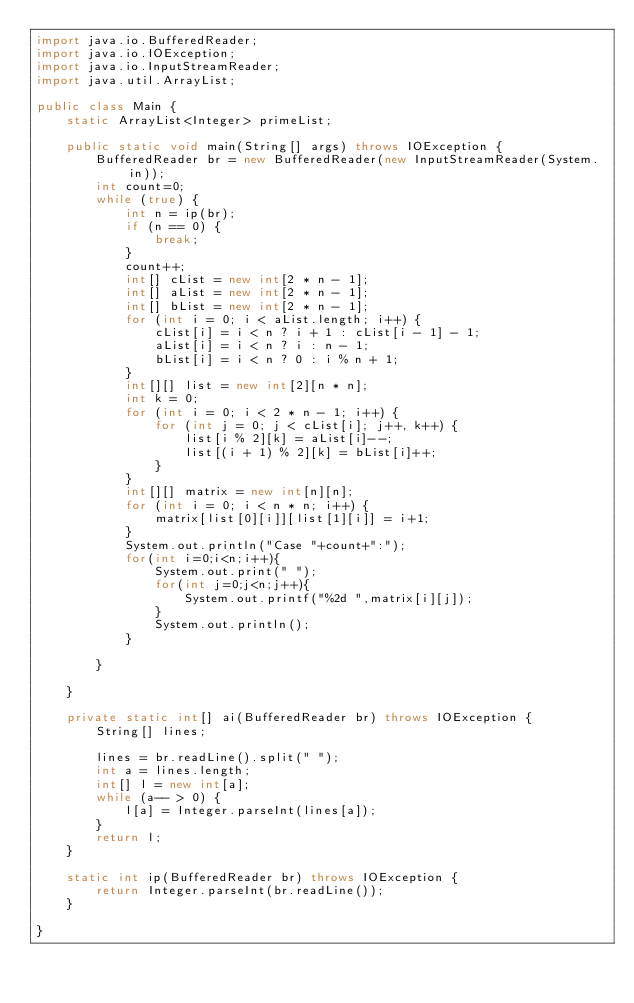Convert code to text. <code><loc_0><loc_0><loc_500><loc_500><_Java_>import java.io.BufferedReader;
import java.io.IOException;
import java.io.InputStreamReader;
import java.util.ArrayList;

public class Main {
    static ArrayList<Integer> primeList;

    public static void main(String[] args) throws IOException {
        BufferedReader br = new BufferedReader(new InputStreamReader(System.in));
        int count=0;
        while (true) {
            int n = ip(br);
            if (n == 0) {
                break;
            }
            count++;
            int[] cList = new int[2 * n - 1];
            int[] aList = new int[2 * n - 1];
            int[] bList = new int[2 * n - 1];
            for (int i = 0; i < aList.length; i++) {
                cList[i] = i < n ? i + 1 : cList[i - 1] - 1;
                aList[i] = i < n ? i : n - 1;
                bList[i] = i < n ? 0 : i % n + 1;
            }
            int[][] list = new int[2][n * n];
            int k = 0;
            for (int i = 0; i < 2 * n - 1; i++) {
                for (int j = 0; j < cList[i]; j++, k++) {
                    list[i % 2][k] = aList[i]--;
                    list[(i + 1) % 2][k] = bList[i]++;
                }
            }
            int[][] matrix = new int[n][n];
            for (int i = 0; i < n * n; i++) {
                matrix[list[0][i]][list[1][i]] = i+1;
            }
            System.out.println("Case "+count+":");
            for(int i=0;i<n;i++){
                System.out.print(" ");
                for(int j=0;j<n;j++){
                    System.out.printf("%2d ",matrix[i][j]);
                }
                System.out.println();
            }

        }

    }

    private static int[] ai(BufferedReader br) throws IOException {
        String[] lines;

        lines = br.readLine().split(" ");
        int a = lines.length;
        int[] l = new int[a];
        while (a-- > 0) {
            l[a] = Integer.parseInt(lines[a]);
        }
        return l;
    }

    static int ip(BufferedReader br) throws IOException {
        return Integer.parseInt(br.readLine());
    }

}</code> 